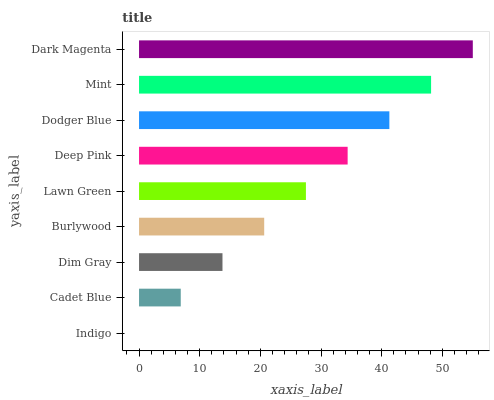Is Indigo the minimum?
Answer yes or no. Yes. Is Dark Magenta the maximum?
Answer yes or no. Yes. Is Cadet Blue the minimum?
Answer yes or no. No. Is Cadet Blue the maximum?
Answer yes or no. No. Is Cadet Blue greater than Indigo?
Answer yes or no. Yes. Is Indigo less than Cadet Blue?
Answer yes or no. Yes. Is Indigo greater than Cadet Blue?
Answer yes or no. No. Is Cadet Blue less than Indigo?
Answer yes or no. No. Is Lawn Green the high median?
Answer yes or no. Yes. Is Lawn Green the low median?
Answer yes or no. Yes. Is Cadet Blue the high median?
Answer yes or no. No. Is Indigo the low median?
Answer yes or no. No. 